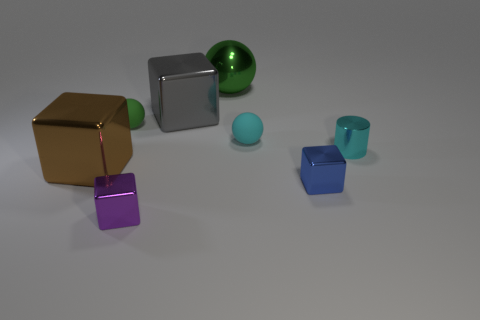How many other objects are the same size as the gray cube?
Your response must be concise. 2. Does the object in front of the blue metal block have the same shape as the tiny cyan matte thing?
Make the answer very short. No. There is a purple block in front of the small cylinder; what is its material?
Offer a terse response. Metal. What is the shape of the object that is the same color as the tiny cylinder?
Keep it short and to the point. Sphere. Are there any small cyan cylinders made of the same material as the big gray object?
Provide a short and direct response. Yes. What is the size of the cyan ball?
Provide a succinct answer. Small. What number of cyan things are either large metal cubes or cylinders?
Your answer should be compact. 1. What number of other small things have the same shape as the tiny blue metallic object?
Provide a succinct answer. 1. What number of metal cylinders have the same size as the blue metallic object?
Your response must be concise. 1. What material is the purple thing that is the same shape as the brown metallic object?
Your answer should be compact. Metal. 